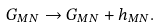<formula> <loc_0><loc_0><loc_500><loc_500>G _ { M N } \to G _ { M N } + h _ { M N } .</formula> 